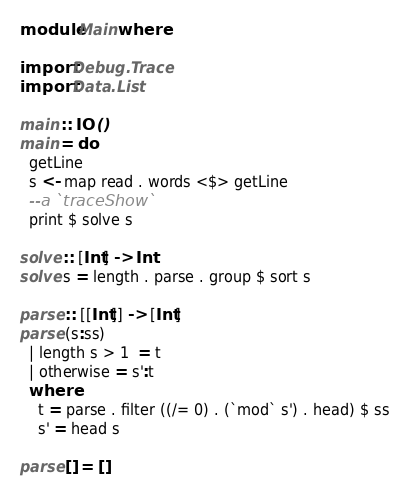Convert code to text. <code><loc_0><loc_0><loc_500><loc_500><_Haskell_>
module Main where

import Debug.Trace
import Data.List

main :: IO ()
main = do
  getLine
  s <- map read . words <$> getLine 
  --a `traceShow`
  print $ solve s

solve :: [Int] -> Int
solve s = length . parse . group $ sort s

parse :: [[Int]] -> [Int]
parse (s:ss)
  | length s > 1  = t
  | otherwise = s':t
  where
    t = parse . filter ((/= 0) . (`mod` s') . head) $ ss
    s' = head s

parse [] = []
</code> 